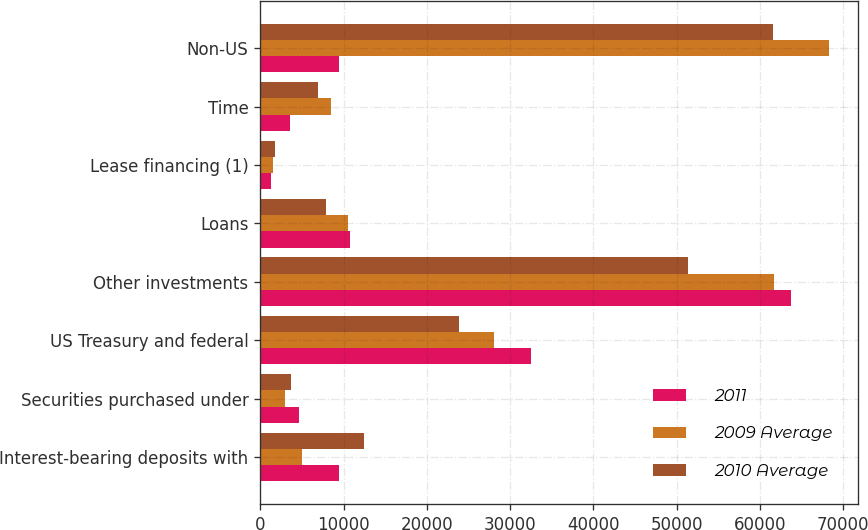<chart> <loc_0><loc_0><loc_500><loc_500><stacked_bar_chart><ecel><fcel>Interest-bearing deposits with<fcel>Securities purchased under<fcel>US Treasury and federal<fcel>Other investments<fcel>Loans<fcel>Lease financing (1)<fcel>Time<fcel>Non-US<nl><fcel>2011<fcel>9505<fcel>4686<fcel>32517<fcel>63683<fcel>10834<fcel>1346<fcel>3626<fcel>9505<nl><fcel>2009 Average<fcel>4983<fcel>2957<fcel>28028<fcel>61651<fcel>10557<fcel>1537<fcel>8485<fcel>68326<nl><fcel>2010 Average<fcel>12418<fcel>3701<fcel>23892<fcel>51340<fcel>7934<fcel>1769<fcel>6905<fcel>61551<nl></chart> 